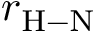Convert formula to latex. <formula><loc_0><loc_0><loc_500><loc_500>r _ { H - N }</formula> 